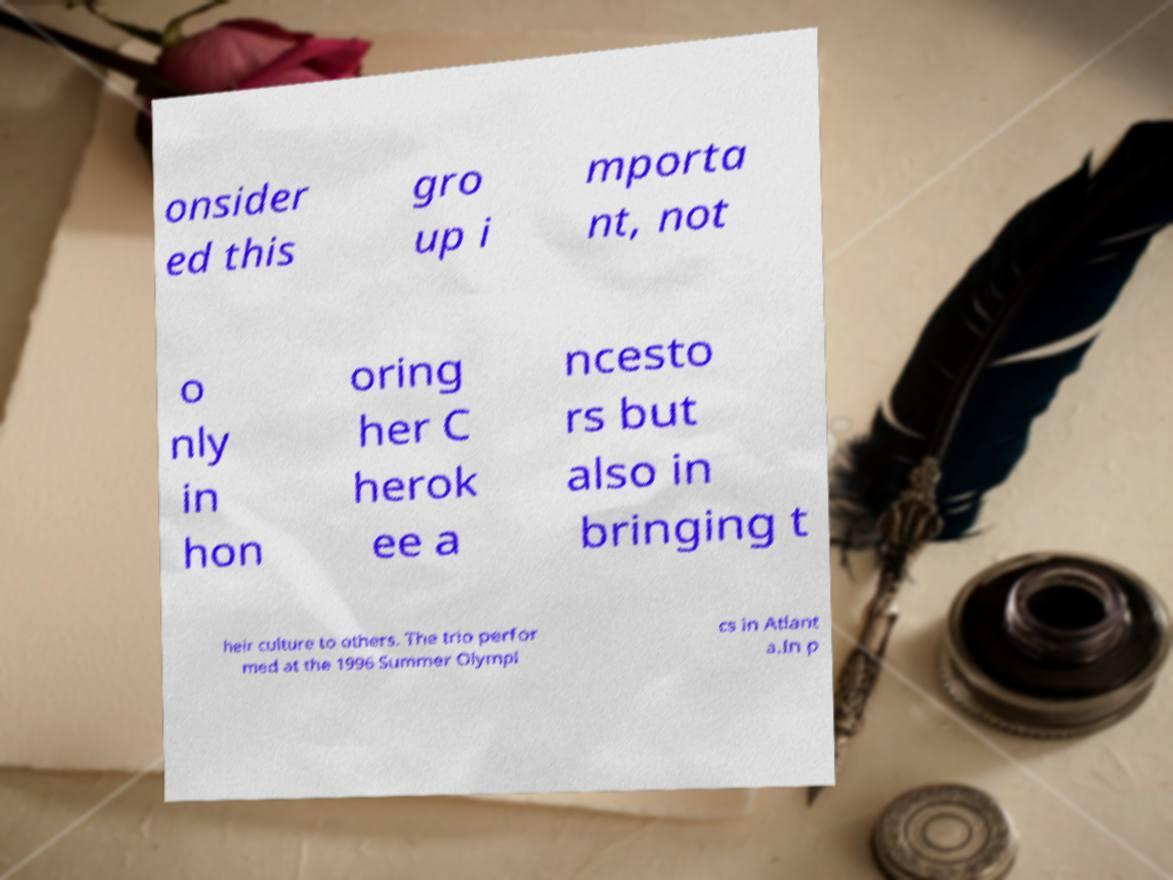For documentation purposes, I need the text within this image transcribed. Could you provide that? onsider ed this gro up i mporta nt, not o nly in hon oring her C herok ee a ncesto rs but also in bringing t heir culture to others. The trio perfor med at the 1996 Summer Olympi cs in Atlant a.In p 